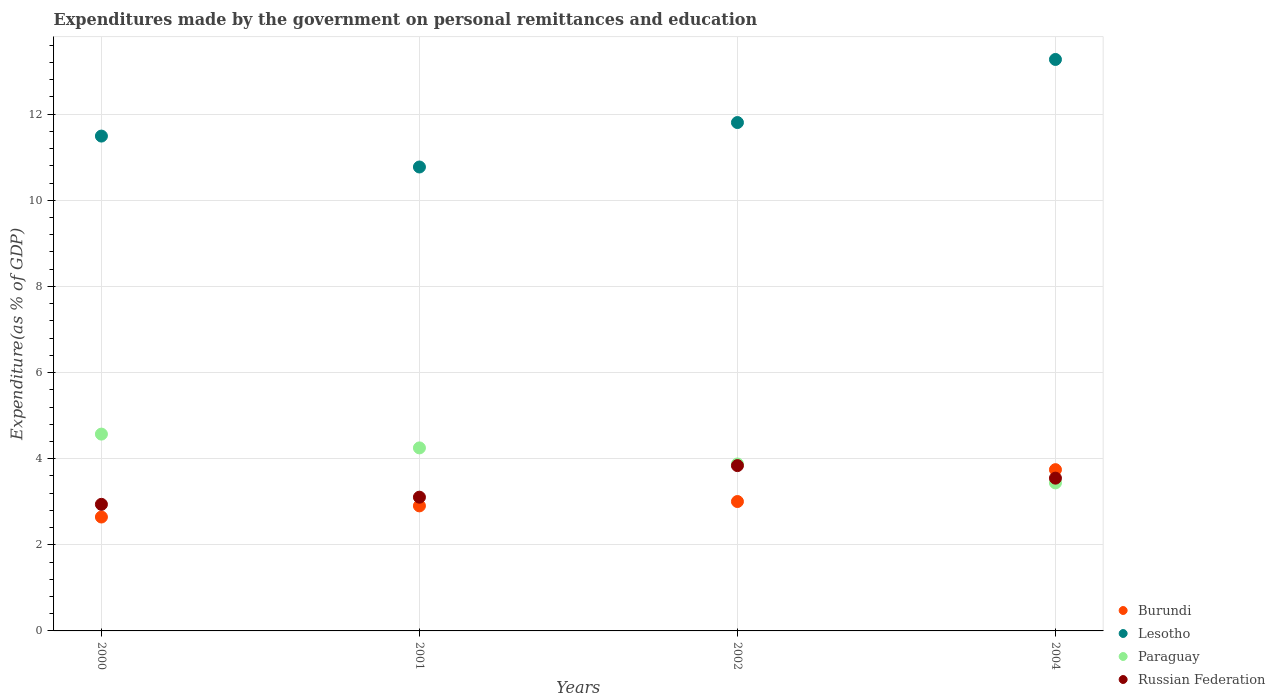What is the expenditures made by the government on personal remittances and education in Burundi in 2004?
Give a very brief answer. 3.74. Across all years, what is the maximum expenditures made by the government on personal remittances and education in Lesotho?
Your answer should be very brief. 13.27. Across all years, what is the minimum expenditures made by the government on personal remittances and education in Burundi?
Provide a short and direct response. 2.65. In which year was the expenditures made by the government on personal remittances and education in Russian Federation minimum?
Provide a short and direct response. 2000. What is the total expenditures made by the government on personal remittances and education in Paraguay in the graph?
Your answer should be very brief. 16.14. What is the difference between the expenditures made by the government on personal remittances and education in Paraguay in 2001 and that in 2002?
Make the answer very short. 0.37. What is the difference between the expenditures made by the government on personal remittances and education in Paraguay in 2002 and the expenditures made by the government on personal remittances and education in Lesotho in 2000?
Your answer should be very brief. -7.61. What is the average expenditures made by the government on personal remittances and education in Burundi per year?
Your answer should be compact. 3.07. In the year 2004, what is the difference between the expenditures made by the government on personal remittances and education in Paraguay and expenditures made by the government on personal remittances and education in Russian Federation?
Make the answer very short. -0.11. In how many years, is the expenditures made by the government on personal remittances and education in Paraguay greater than 9.2 %?
Your answer should be very brief. 0. What is the ratio of the expenditures made by the government on personal remittances and education in Lesotho in 2000 to that in 2004?
Your response must be concise. 0.87. Is the difference between the expenditures made by the government on personal remittances and education in Paraguay in 2002 and 2004 greater than the difference between the expenditures made by the government on personal remittances and education in Russian Federation in 2002 and 2004?
Keep it short and to the point. Yes. What is the difference between the highest and the second highest expenditures made by the government on personal remittances and education in Paraguay?
Your answer should be compact. 0.32. What is the difference between the highest and the lowest expenditures made by the government on personal remittances and education in Burundi?
Keep it short and to the point. 1.1. Is it the case that in every year, the sum of the expenditures made by the government on personal remittances and education in Lesotho and expenditures made by the government on personal remittances and education in Burundi  is greater than the sum of expenditures made by the government on personal remittances and education in Paraguay and expenditures made by the government on personal remittances and education in Russian Federation?
Offer a very short reply. Yes. Does the expenditures made by the government on personal remittances and education in Burundi monotonically increase over the years?
Keep it short and to the point. Yes. How many years are there in the graph?
Give a very brief answer. 4. Are the values on the major ticks of Y-axis written in scientific E-notation?
Keep it short and to the point. No. Does the graph contain any zero values?
Offer a terse response. No. Does the graph contain grids?
Your answer should be compact. Yes. Where does the legend appear in the graph?
Ensure brevity in your answer.  Bottom right. How many legend labels are there?
Give a very brief answer. 4. How are the legend labels stacked?
Give a very brief answer. Vertical. What is the title of the graph?
Provide a succinct answer. Expenditures made by the government on personal remittances and education. Does "Colombia" appear as one of the legend labels in the graph?
Offer a terse response. No. What is the label or title of the X-axis?
Make the answer very short. Years. What is the label or title of the Y-axis?
Keep it short and to the point. Expenditure(as % of GDP). What is the Expenditure(as % of GDP) in Burundi in 2000?
Provide a short and direct response. 2.65. What is the Expenditure(as % of GDP) in Lesotho in 2000?
Offer a very short reply. 11.49. What is the Expenditure(as % of GDP) in Paraguay in 2000?
Give a very brief answer. 4.57. What is the Expenditure(as % of GDP) of Russian Federation in 2000?
Provide a succinct answer. 2.94. What is the Expenditure(as % of GDP) in Burundi in 2001?
Ensure brevity in your answer.  2.9. What is the Expenditure(as % of GDP) of Lesotho in 2001?
Keep it short and to the point. 10.77. What is the Expenditure(as % of GDP) of Paraguay in 2001?
Keep it short and to the point. 4.25. What is the Expenditure(as % of GDP) in Russian Federation in 2001?
Your response must be concise. 3.11. What is the Expenditure(as % of GDP) of Burundi in 2002?
Offer a terse response. 3. What is the Expenditure(as % of GDP) in Lesotho in 2002?
Ensure brevity in your answer.  11.81. What is the Expenditure(as % of GDP) in Paraguay in 2002?
Offer a very short reply. 3.88. What is the Expenditure(as % of GDP) of Russian Federation in 2002?
Your answer should be compact. 3.84. What is the Expenditure(as % of GDP) in Burundi in 2004?
Your response must be concise. 3.74. What is the Expenditure(as % of GDP) of Lesotho in 2004?
Your answer should be very brief. 13.27. What is the Expenditure(as % of GDP) of Paraguay in 2004?
Your answer should be very brief. 3.44. What is the Expenditure(as % of GDP) of Russian Federation in 2004?
Offer a terse response. 3.55. Across all years, what is the maximum Expenditure(as % of GDP) of Burundi?
Offer a very short reply. 3.74. Across all years, what is the maximum Expenditure(as % of GDP) in Lesotho?
Make the answer very short. 13.27. Across all years, what is the maximum Expenditure(as % of GDP) of Paraguay?
Offer a terse response. 4.57. Across all years, what is the maximum Expenditure(as % of GDP) of Russian Federation?
Provide a succinct answer. 3.84. Across all years, what is the minimum Expenditure(as % of GDP) in Burundi?
Provide a short and direct response. 2.65. Across all years, what is the minimum Expenditure(as % of GDP) of Lesotho?
Ensure brevity in your answer.  10.77. Across all years, what is the minimum Expenditure(as % of GDP) in Paraguay?
Provide a succinct answer. 3.44. Across all years, what is the minimum Expenditure(as % of GDP) of Russian Federation?
Your response must be concise. 2.94. What is the total Expenditure(as % of GDP) of Burundi in the graph?
Offer a terse response. 12.3. What is the total Expenditure(as % of GDP) of Lesotho in the graph?
Make the answer very short. 47.34. What is the total Expenditure(as % of GDP) of Paraguay in the graph?
Your answer should be very brief. 16.14. What is the total Expenditure(as % of GDP) in Russian Federation in the graph?
Make the answer very short. 13.43. What is the difference between the Expenditure(as % of GDP) in Burundi in 2000 and that in 2001?
Ensure brevity in your answer.  -0.26. What is the difference between the Expenditure(as % of GDP) of Lesotho in 2000 and that in 2001?
Provide a short and direct response. 0.72. What is the difference between the Expenditure(as % of GDP) in Paraguay in 2000 and that in 2001?
Give a very brief answer. 0.32. What is the difference between the Expenditure(as % of GDP) of Russian Federation in 2000 and that in 2001?
Your answer should be compact. -0.17. What is the difference between the Expenditure(as % of GDP) of Burundi in 2000 and that in 2002?
Your response must be concise. -0.36. What is the difference between the Expenditure(as % of GDP) of Lesotho in 2000 and that in 2002?
Provide a short and direct response. -0.31. What is the difference between the Expenditure(as % of GDP) of Paraguay in 2000 and that in 2002?
Make the answer very short. 0.69. What is the difference between the Expenditure(as % of GDP) in Russian Federation in 2000 and that in 2002?
Provide a succinct answer. -0.9. What is the difference between the Expenditure(as % of GDP) in Burundi in 2000 and that in 2004?
Provide a succinct answer. -1.1. What is the difference between the Expenditure(as % of GDP) of Lesotho in 2000 and that in 2004?
Provide a short and direct response. -1.78. What is the difference between the Expenditure(as % of GDP) of Paraguay in 2000 and that in 2004?
Make the answer very short. 1.13. What is the difference between the Expenditure(as % of GDP) in Russian Federation in 2000 and that in 2004?
Your response must be concise. -0.61. What is the difference between the Expenditure(as % of GDP) in Burundi in 2001 and that in 2002?
Provide a succinct answer. -0.1. What is the difference between the Expenditure(as % of GDP) in Lesotho in 2001 and that in 2002?
Your response must be concise. -1.03. What is the difference between the Expenditure(as % of GDP) of Paraguay in 2001 and that in 2002?
Your answer should be very brief. 0.37. What is the difference between the Expenditure(as % of GDP) of Russian Federation in 2001 and that in 2002?
Your answer should be very brief. -0.73. What is the difference between the Expenditure(as % of GDP) of Burundi in 2001 and that in 2004?
Your response must be concise. -0.84. What is the difference between the Expenditure(as % of GDP) of Lesotho in 2001 and that in 2004?
Provide a succinct answer. -2.5. What is the difference between the Expenditure(as % of GDP) of Paraguay in 2001 and that in 2004?
Provide a short and direct response. 0.81. What is the difference between the Expenditure(as % of GDP) of Russian Federation in 2001 and that in 2004?
Provide a succinct answer. -0.44. What is the difference between the Expenditure(as % of GDP) of Burundi in 2002 and that in 2004?
Offer a terse response. -0.74. What is the difference between the Expenditure(as % of GDP) in Lesotho in 2002 and that in 2004?
Ensure brevity in your answer.  -1.47. What is the difference between the Expenditure(as % of GDP) in Paraguay in 2002 and that in 2004?
Give a very brief answer. 0.44. What is the difference between the Expenditure(as % of GDP) in Russian Federation in 2002 and that in 2004?
Offer a very short reply. 0.29. What is the difference between the Expenditure(as % of GDP) of Burundi in 2000 and the Expenditure(as % of GDP) of Lesotho in 2001?
Offer a terse response. -8.13. What is the difference between the Expenditure(as % of GDP) of Burundi in 2000 and the Expenditure(as % of GDP) of Paraguay in 2001?
Your answer should be compact. -1.6. What is the difference between the Expenditure(as % of GDP) in Burundi in 2000 and the Expenditure(as % of GDP) in Russian Federation in 2001?
Give a very brief answer. -0.46. What is the difference between the Expenditure(as % of GDP) of Lesotho in 2000 and the Expenditure(as % of GDP) of Paraguay in 2001?
Your answer should be very brief. 7.24. What is the difference between the Expenditure(as % of GDP) of Lesotho in 2000 and the Expenditure(as % of GDP) of Russian Federation in 2001?
Keep it short and to the point. 8.39. What is the difference between the Expenditure(as % of GDP) in Paraguay in 2000 and the Expenditure(as % of GDP) in Russian Federation in 2001?
Offer a terse response. 1.46. What is the difference between the Expenditure(as % of GDP) in Burundi in 2000 and the Expenditure(as % of GDP) in Lesotho in 2002?
Keep it short and to the point. -9.16. What is the difference between the Expenditure(as % of GDP) of Burundi in 2000 and the Expenditure(as % of GDP) of Paraguay in 2002?
Give a very brief answer. -1.23. What is the difference between the Expenditure(as % of GDP) of Burundi in 2000 and the Expenditure(as % of GDP) of Russian Federation in 2002?
Your response must be concise. -1.19. What is the difference between the Expenditure(as % of GDP) in Lesotho in 2000 and the Expenditure(as % of GDP) in Paraguay in 2002?
Offer a terse response. 7.62. What is the difference between the Expenditure(as % of GDP) of Lesotho in 2000 and the Expenditure(as % of GDP) of Russian Federation in 2002?
Make the answer very short. 7.65. What is the difference between the Expenditure(as % of GDP) of Paraguay in 2000 and the Expenditure(as % of GDP) of Russian Federation in 2002?
Your response must be concise. 0.73. What is the difference between the Expenditure(as % of GDP) in Burundi in 2000 and the Expenditure(as % of GDP) in Lesotho in 2004?
Offer a terse response. -10.63. What is the difference between the Expenditure(as % of GDP) in Burundi in 2000 and the Expenditure(as % of GDP) in Paraguay in 2004?
Provide a succinct answer. -0.79. What is the difference between the Expenditure(as % of GDP) in Burundi in 2000 and the Expenditure(as % of GDP) in Russian Federation in 2004?
Your answer should be compact. -0.9. What is the difference between the Expenditure(as % of GDP) in Lesotho in 2000 and the Expenditure(as % of GDP) in Paraguay in 2004?
Your answer should be compact. 8.05. What is the difference between the Expenditure(as % of GDP) in Lesotho in 2000 and the Expenditure(as % of GDP) in Russian Federation in 2004?
Give a very brief answer. 7.94. What is the difference between the Expenditure(as % of GDP) in Paraguay in 2000 and the Expenditure(as % of GDP) in Russian Federation in 2004?
Your answer should be very brief. 1.02. What is the difference between the Expenditure(as % of GDP) in Burundi in 2001 and the Expenditure(as % of GDP) in Lesotho in 2002?
Your answer should be compact. -8.9. What is the difference between the Expenditure(as % of GDP) in Burundi in 2001 and the Expenditure(as % of GDP) in Paraguay in 2002?
Offer a terse response. -0.97. What is the difference between the Expenditure(as % of GDP) of Burundi in 2001 and the Expenditure(as % of GDP) of Russian Federation in 2002?
Your answer should be compact. -0.94. What is the difference between the Expenditure(as % of GDP) of Lesotho in 2001 and the Expenditure(as % of GDP) of Paraguay in 2002?
Offer a terse response. 6.9. What is the difference between the Expenditure(as % of GDP) in Lesotho in 2001 and the Expenditure(as % of GDP) in Russian Federation in 2002?
Offer a terse response. 6.93. What is the difference between the Expenditure(as % of GDP) of Paraguay in 2001 and the Expenditure(as % of GDP) of Russian Federation in 2002?
Offer a terse response. 0.41. What is the difference between the Expenditure(as % of GDP) of Burundi in 2001 and the Expenditure(as % of GDP) of Lesotho in 2004?
Provide a succinct answer. -10.37. What is the difference between the Expenditure(as % of GDP) in Burundi in 2001 and the Expenditure(as % of GDP) in Paraguay in 2004?
Your answer should be compact. -0.53. What is the difference between the Expenditure(as % of GDP) of Burundi in 2001 and the Expenditure(as % of GDP) of Russian Federation in 2004?
Keep it short and to the point. -0.64. What is the difference between the Expenditure(as % of GDP) in Lesotho in 2001 and the Expenditure(as % of GDP) in Paraguay in 2004?
Your answer should be compact. 7.34. What is the difference between the Expenditure(as % of GDP) of Lesotho in 2001 and the Expenditure(as % of GDP) of Russian Federation in 2004?
Ensure brevity in your answer.  7.23. What is the difference between the Expenditure(as % of GDP) in Paraguay in 2001 and the Expenditure(as % of GDP) in Russian Federation in 2004?
Provide a short and direct response. 0.7. What is the difference between the Expenditure(as % of GDP) of Burundi in 2002 and the Expenditure(as % of GDP) of Lesotho in 2004?
Your answer should be very brief. -10.27. What is the difference between the Expenditure(as % of GDP) in Burundi in 2002 and the Expenditure(as % of GDP) in Paraguay in 2004?
Your response must be concise. -0.43. What is the difference between the Expenditure(as % of GDP) in Burundi in 2002 and the Expenditure(as % of GDP) in Russian Federation in 2004?
Keep it short and to the point. -0.54. What is the difference between the Expenditure(as % of GDP) of Lesotho in 2002 and the Expenditure(as % of GDP) of Paraguay in 2004?
Give a very brief answer. 8.37. What is the difference between the Expenditure(as % of GDP) of Lesotho in 2002 and the Expenditure(as % of GDP) of Russian Federation in 2004?
Make the answer very short. 8.26. What is the difference between the Expenditure(as % of GDP) of Paraguay in 2002 and the Expenditure(as % of GDP) of Russian Federation in 2004?
Provide a succinct answer. 0.33. What is the average Expenditure(as % of GDP) of Burundi per year?
Give a very brief answer. 3.07. What is the average Expenditure(as % of GDP) of Lesotho per year?
Provide a succinct answer. 11.84. What is the average Expenditure(as % of GDP) of Paraguay per year?
Give a very brief answer. 4.03. What is the average Expenditure(as % of GDP) in Russian Federation per year?
Provide a short and direct response. 3.36. In the year 2000, what is the difference between the Expenditure(as % of GDP) in Burundi and Expenditure(as % of GDP) in Lesotho?
Give a very brief answer. -8.85. In the year 2000, what is the difference between the Expenditure(as % of GDP) of Burundi and Expenditure(as % of GDP) of Paraguay?
Ensure brevity in your answer.  -1.93. In the year 2000, what is the difference between the Expenditure(as % of GDP) of Burundi and Expenditure(as % of GDP) of Russian Federation?
Ensure brevity in your answer.  -0.29. In the year 2000, what is the difference between the Expenditure(as % of GDP) in Lesotho and Expenditure(as % of GDP) in Paraguay?
Your answer should be compact. 6.92. In the year 2000, what is the difference between the Expenditure(as % of GDP) of Lesotho and Expenditure(as % of GDP) of Russian Federation?
Offer a very short reply. 8.55. In the year 2000, what is the difference between the Expenditure(as % of GDP) in Paraguay and Expenditure(as % of GDP) in Russian Federation?
Make the answer very short. 1.63. In the year 2001, what is the difference between the Expenditure(as % of GDP) in Burundi and Expenditure(as % of GDP) in Lesotho?
Ensure brevity in your answer.  -7.87. In the year 2001, what is the difference between the Expenditure(as % of GDP) in Burundi and Expenditure(as % of GDP) in Paraguay?
Keep it short and to the point. -1.35. In the year 2001, what is the difference between the Expenditure(as % of GDP) in Burundi and Expenditure(as % of GDP) in Russian Federation?
Make the answer very short. -0.2. In the year 2001, what is the difference between the Expenditure(as % of GDP) in Lesotho and Expenditure(as % of GDP) in Paraguay?
Offer a terse response. 6.52. In the year 2001, what is the difference between the Expenditure(as % of GDP) of Lesotho and Expenditure(as % of GDP) of Russian Federation?
Give a very brief answer. 7.67. In the year 2001, what is the difference between the Expenditure(as % of GDP) of Paraguay and Expenditure(as % of GDP) of Russian Federation?
Make the answer very short. 1.14. In the year 2002, what is the difference between the Expenditure(as % of GDP) in Burundi and Expenditure(as % of GDP) in Lesotho?
Your answer should be compact. -8.8. In the year 2002, what is the difference between the Expenditure(as % of GDP) in Burundi and Expenditure(as % of GDP) in Paraguay?
Give a very brief answer. -0.87. In the year 2002, what is the difference between the Expenditure(as % of GDP) in Burundi and Expenditure(as % of GDP) in Russian Federation?
Provide a succinct answer. -0.83. In the year 2002, what is the difference between the Expenditure(as % of GDP) of Lesotho and Expenditure(as % of GDP) of Paraguay?
Keep it short and to the point. 7.93. In the year 2002, what is the difference between the Expenditure(as % of GDP) in Lesotho and Expenditure(as % of GDP) in Russian Federation?
Give a very brief answer. 7.97. In the year 2002, what is the difference between the Expenditure(as % of GDP) in Paraguay and Expenditure(as % of GDP) in Russian Federation?
Your response must be concise. 0.04. In the year 2004, what is the difference between the Expenditure(as % of GDP) of Burundi and Expenditure(as % of GDP) of Lesotho?
Provide a short and direct response. -9.53. In the year 2004, what is the difference between the Expenditure(as % of GDP) of Burundi and Expenditure(as % of GDP) of Paraguay?
Your answer should be compact. 0.31. In the year 2004, what is the difference between the Expenditure(as % of GDP) of Burundi and Expenditure(as % of GDP) of Russian Federation?
Make the answer very short. 0.2. In the year 2004, what is the difference between the Expenditure(as % of GDP) of Lesotho and Expenditure(as % of GDP) of Paraguay?
Ensure brevity in your answer.  9.83. In the year 2004, what is the difference between the Expenditure(as % of GDP) in Lesotho and Expenditure(as % of GDP) in Russian Federation?
Give a very brief answer. 9.72. In the year 2004, what is the difference between the Expenditure(as % of GDP) in Paraguay and Expenditure(as % of GDP) in Russian Federation?
Ensure brevity in your answer.  -0.11. What is the ratio of the Expenditure(as % of GDP) in Burundi in 2000 to that in 2001?
Make the answer very short. 0.91. What is the ratio of the Expenditure(as % of GDP) of Lesotho in 2000 to that in 2001?
Offer a very short reply. 1.07. What is the ratio of the Expenditure(as % of GDP) of Paraguay in 2000 to that in 2001?
Provide a short and direct response. 1.08. What is the ratio of the Expenditure(as % of GDP) in Russian Federation in 2000 to that in 2001?
Your response must be concise. 0.95. What is the ratio of the Expenditure(as % of GDP) in Burundi in 2000 to that in 2002?
Your answer should be very brief. 0.88. What is the ratio of the Expenditure(as % of GDP) in Lesotho in 2000 to that in 2002?
Your answer should be compact. 0.97. What is the ratio of the Expenditure(as % of GDP) of Paraguay in 2000 to that in 2002?
Offer a very short reply. 1.18. What is the ratio of the Expenditure(as % of GDP) in Russian Federation in 2000 to that in 2002?
Provide a short and direct response. 0.77. What is the ratio of the Expenditure(as % of GDP) in Burundi in 2000 to that in 2004?
Keep it short and to the point. 0.71. What is the ratio of the Expenditure(as % of GDP) of Lesotho in 2000 to that in 2004?
Ensure brevity in your answer.  0.87. What is the ratio of the Expenditure(as % of GDP) of Paraguay in 2000 to that in 2004?
Make the answer very short. 1.33. What is the ratio of the Expenditure(as % of GDP) in Russian Federation in 2000 to that in 2004?
Offer a terse response. 0.83. What is the ratio of the Expenditure(as % of GDP) of Burundi in 2001 to that in 2002?
Give a very brief answer. 0.97. What is the ratio of the Expenditure(as % of GDP) of Lesotho in 2001 to that in 2002?
Give a very brief answer. 0.91. What is the ratio of the Expenditure(as % of GDP) in Paraguay in 2001 to that in 2002?
Make the answer very short. 1.1. What is the ratio of the Expenditure(as % of GDP) of Russian Federation in 2001 to that in 2002?
Your answer should be compact. 0.81. What is the ratio of the Expenditure(as % of GDP) in Burundi in 2001 to that in 2004?
Ensure brevity in your answer.  0.78. What is the ratio of the Expenditure(as % of GDP) in Lesotho in 2001 to that in 2004?
Offer a terse response. 0.81. What is the ratio of the Expenditure(as % of GDP) in Paraguay in 2001 to that in 2004?
Give a very brief answer. 1.24. What is the ratio of the Expenditure(as % of GDP) in Russian Federation in 2001 to that in 2004?
Make the answer very short. 0.88. What is the ratio of the Expenditure(as % of GDP) in Burundi in 2002 to that in 2004?
Ensure brevity in your answer.  0.8. What is the ratio of the Expenditure(as % of GDP) in Lesotho in 2002 to that in 2004?
Make the answer very short. 0.89. What is the ratio of the Expenditure(as % of GDP) in Paraguay in 2002 to that in 2004?
Give a very brief answer. 1.13. What is the ratio of the Expenditure(as % of GDP) of Russian Federation in 2002 to that in 2004?
Keep it short and to the point. 1.08. What is the difference between the highest and the second highest Expenditure(as % of GDP) of Burundi?
Your answer should be very brief. 0.74. What is the difference between the highest and the second highest Expenditure(as % of GDP) of Lesotho?
Give a very brief answer. 1.47. What is the difference between the highest and the second highest Expenditure(as % of GDP) in Paraguay?
Keep it short and to the point. 0.32. What is the difference between the highest and the second highest Expenditure(as % of GDP) of Russian Federation?
Provide a short and direct response. 0.29. What is the difference between the highest and the lowest Expenditure(as % of GDP) in Burundi?
Provide a short and direct response. 1.1. What is the difference between the highest and the lowest Expenditure(as % of GDP) in Lesotho?
Keep it short and to the point. 2.5. What is the difference between the highest and the lowest Expenditure(as % of GDP) in Paraguay?
Make the answer very short. 1.13. What is the difference between the highest and the lowest Expenditure(as % of GDP) in Russian Federation?
Provide a short and direct response. 0.9. 